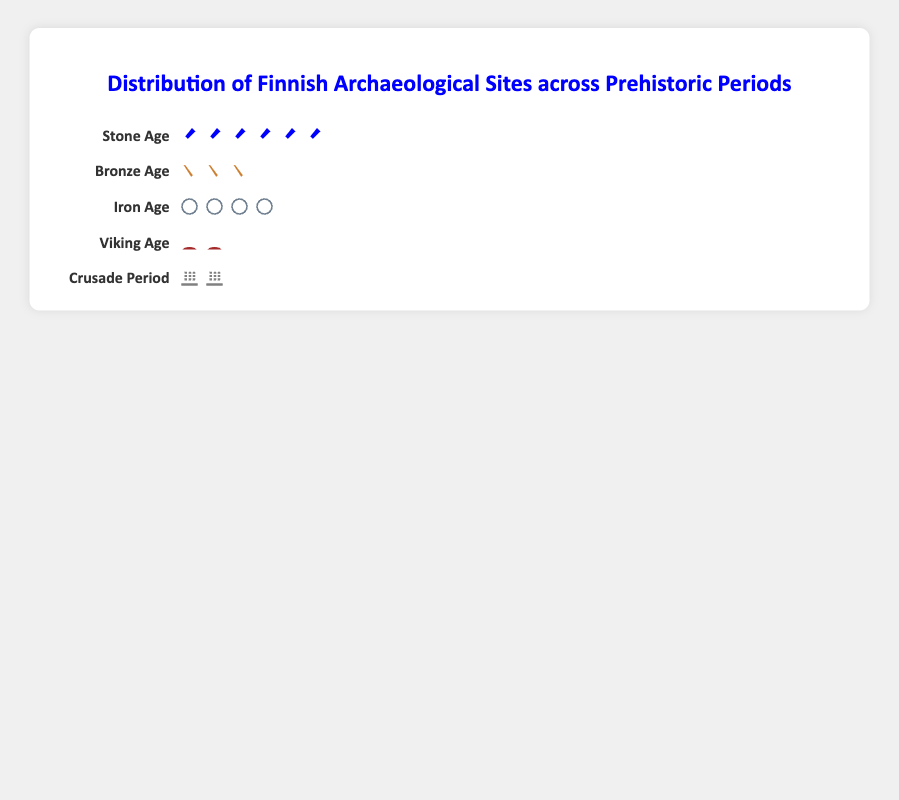Which prehistoric period has the most archaeological sites? The Stone Age has the most archaeological sites as evidenced by the largest number of icons representing it in the plot.
Answer: Stone Age How many sites are represented during the Viking Age? The Viking Age is represented by 2 longship icons. Each icon represents 200 sites, thus multiplying 2 by 200 gives 400.
Answer: 400 Which periods have fewer than 1,000 archaeological sites? The Bronze Age, Viking Age, and Crusade Period have fewer than 1,000 sites with 600, 400, and 300 sites respectively. This can be easily identified by counting the icons for these periods.
Answer: Bronze Age, Viking Age, Crusade Period What is the total number of archaeological sites represented in the plot? Adding up the sites for each age: Stone Age (1200), Bronze Age (600), Iron Age (800), Viking Age (400), and Crusade Period (300), the total is 1200 + 600 + 800 + 400 + 300 = 3300 archaeological sites.
Answer: 3300 Compare the number of sites between the Iron Age and the Crusade Period. The Iron Age has 800 sites while the Crusade Period has 300 sites. The Iron Age has 500 more sites than the Crusade Period, calculated by 800 - 300.
Answer: Iron Age has 500 more What percentage of the total sites does the Stone Age represent? The total number of sites is 3300. The Stone Age has 1200 sites. The percentage is calculated as (1200 / 3300) * 100, which is approximately 36.36%.
Answer: ~36.36% Which period comes immediately after the Iron Age based on the figure layout? Based on the sequential listing in the figure, the Viking Age comes immediately after the Iron Age.
Answer: Viking Age 